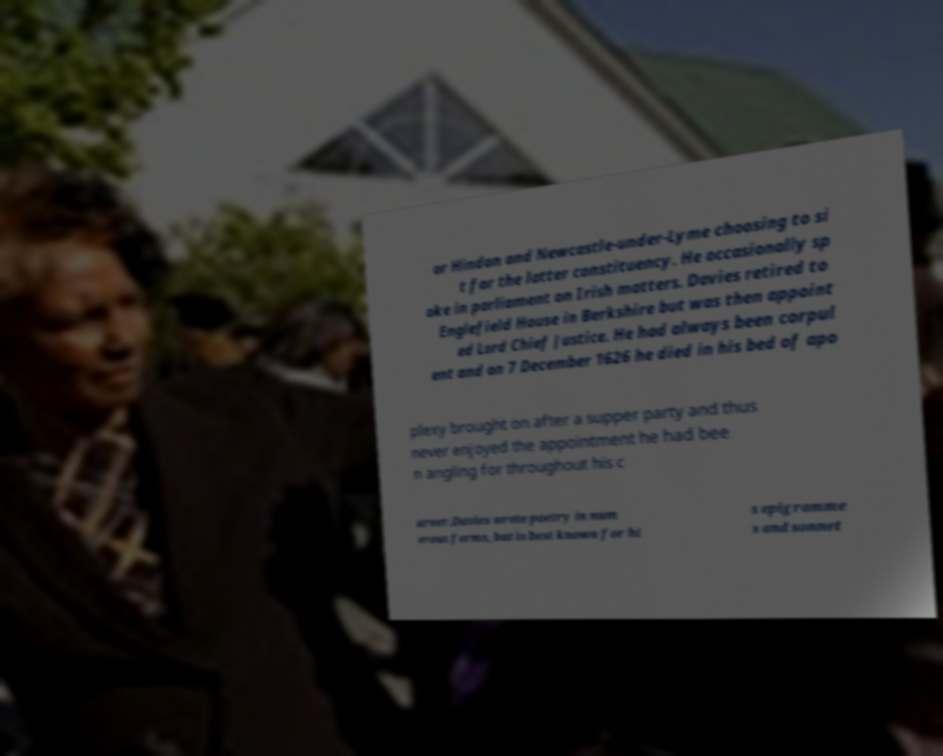There's text embedded in this image that I need extracted. Can you transcribe it verbatim? or Hindon and Newcastle-under-Lyme choosing to si t for the latter constituency. He occasionally sp oke in parliament on Irish matters. Davies retired to Englefield House in Berkshire but was then appoint ed Lord Chief Justice. He had always been corpul ent and on 7 December 1626 he died in his bed of apo plexy brought on after a supper party and thus never enjoyed the appointment he had bee n angling for throughout his c areer.Davies wrote poetry in num erous forms, but is best known for hi s epigramme s and sonnet 